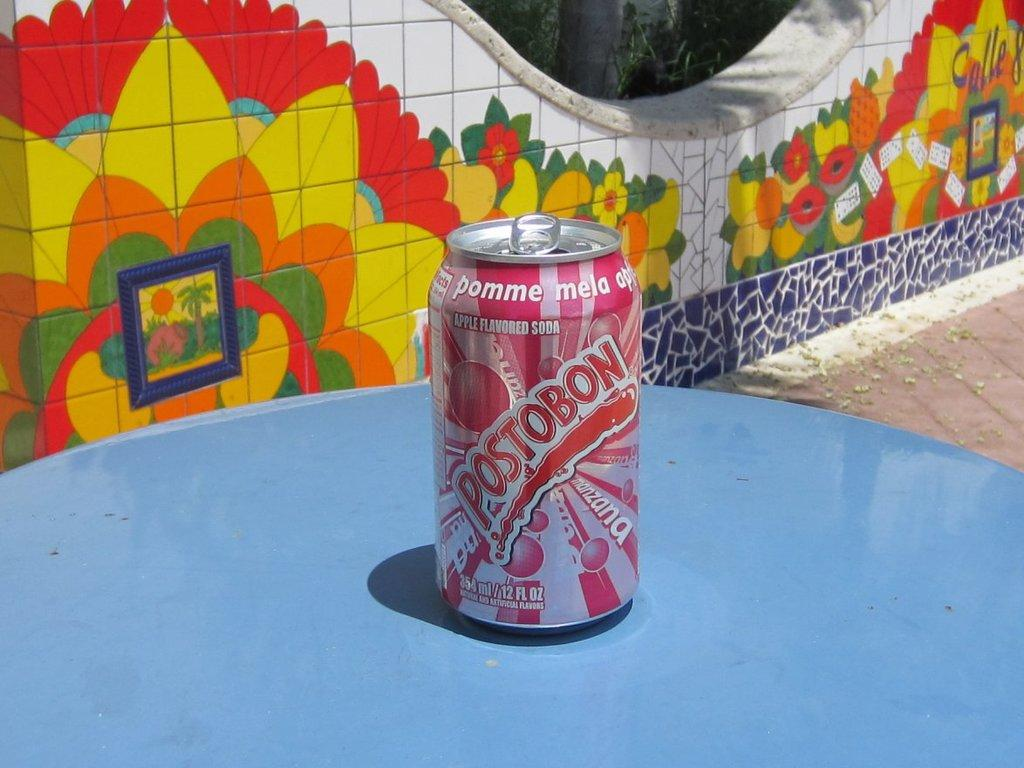<image>
Give a short and clear explanation of the subsequent image. A can of postobon soda sitting on a blue table. 